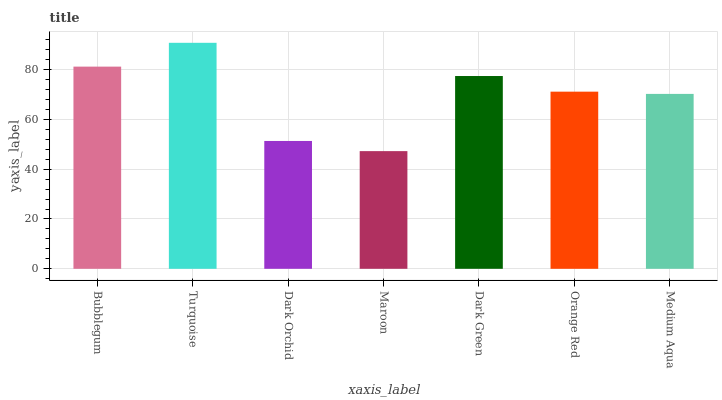Is Maroon the minimum?
Answer yes or no. Yes. Is Turquoise the maximum?
Answer yes or no. Yes. Is Dark Orchid the minimum?
Answer yes or no. No. Is Dark Orchid the maximum?
Answer yes or no. No. Is Turquoise greater than Dark Orchid?
Answer yes or no. Yes. Is Dark Orchid less than Turquoise?
Answer yes or no. Yes. Is Dark Orchid greater than Turquoise?
Answer yes or no. No. Is Turquoise less than Dark Orchid?
Answer yes or no. No. Is Orange Red the high median?
Answer yes or no. Yes. Is Orange Red the low median?
Answer yes or no. Yes. Is Maroon the high median?
Answer yes or no. No. Is Medium Aqua the low median?
Answer yes or no. No. 